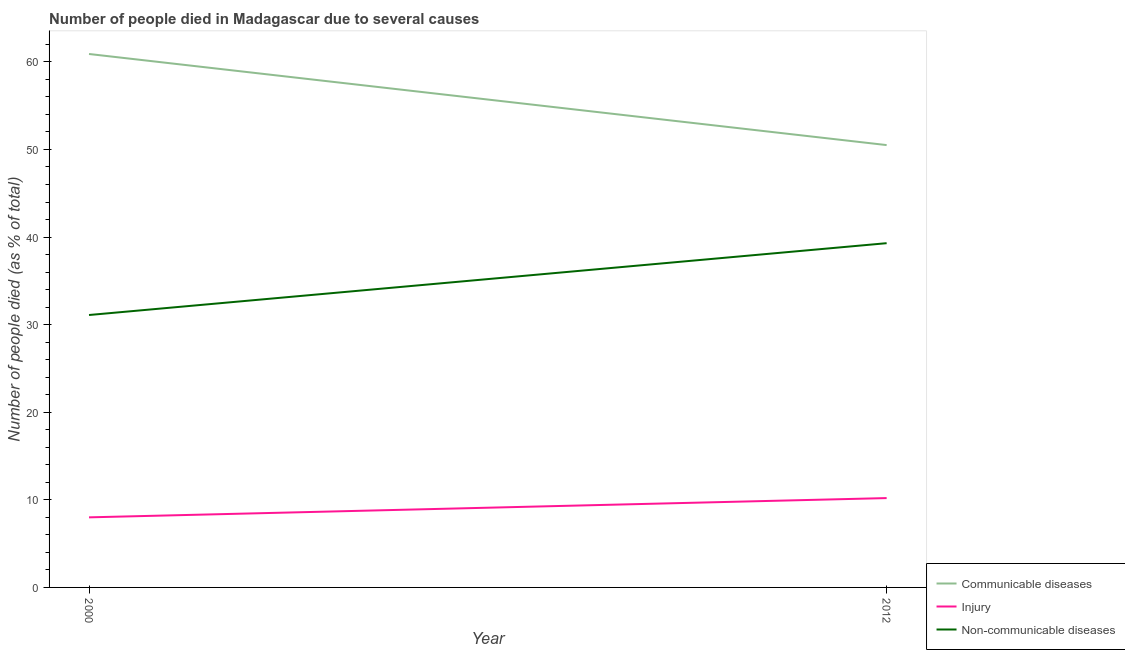Does the line corresponding to number of people who died of communicable diseases intersect with the line corresponding to number of people who died of injury?
Keep it short and to the point. No. Is the number of lines equal to the number of legend labels?
Provide a short and direct response. Yes. What is the number of people who dies of non-communicable diseases in 2012?
Your response must be concise. 39.3. Across all years, what is the maximum number of people who dies of non-communicable diseases?
Give a very brief answer. 39.3. In which year was the number of people who died of injury minimum?
Your answer should be compact. 2000. What is the total number of people who dies of non-communicable diseases in the graph?
Keep it short and to the point. 70.4. What is the difference between the number of people who died of injury in 2000 and that in 2012?
Your response must be concise. -2.2. What is the difference between the number of people who died of communicable diseases in 2012 and the number of people who died of injury in 2000?
Provide a succinct answer. 42.5. What is the average number of people who died of communicable diseases per year?
Give a very brief answer. 55.7. In the year 2012, what is the difference between the number of people who died of injury and number of people who dies of non-communicable diseases?
Offer a terse response. -29.1. In how many years, is the number of people who dies of non-communicable diseases greater than 8 %?
Your response must be concise. 2. What is the ratio of the number of people who died of communicable diseases in 2000 to that in 2012?
Offer a terse response. 1.21. Is the number of people who died of injury in 2000 less than that in 2012?
Keep it short and to the point. Yes. Is it the case that in every year, the sum of the number of people who died of communicable diseases and number of people who died of injury is greater than the number of people who dies of non-communicable diseases?
Keep it short and to the point. Yes. Is the number of people who died of communicable diseases strictly greater than the number of people who died of injury over the years?
Keep it short and to the point. Yes. Is the number of people who died of injury strictly less than the number of people who died of communicable diseases over the years?
Ensure brevity in your answer.  Yes. How many years are there in the graph?
Your response must be concise. 2. Are the values on the major ticks of Y-axis written in scientific E-notation?
Ensure brevity in your answer.  No. Does the graph contain grids?
Your response must be concise. No. Where does the legend appear in the graph?
Your answer should be very brief. Bottom right. What is the title of the graph?
Your answer should be compact. Number of people died in Madagascar due to several causes. What is the label or title of the X-axis?
Keep it short and to the point. Year. What is the label or title of the Y-axis?
Your answer should be compact. Number of people died (as % of total). What is the Number of people died (as % of total) of Communicable diseases in 2000?
Offer a terse response. 60.9. What is the Number of people died (as % of total) in Non-communicable diseases in 2000?
Your response must be concise. 31.1. What is the Number of people died (as % of total) in Communicable diseases in 2012?
Provide a short and direct response. 50.5. What is the Number of people died (as % of total) of Non-communicable diseases in 2012?
Your answer should be very brief. 39.3. Across all years, what is the maximum Number of people died (as % of total) in Communicable diseases?
Make the answer very short. 60.9. Across all years, what is the maximum Number of people died (as % of total) of Non-communicable diseases?
Your answer should be very brief. 39.3. Across all years, what is the minimum Number of people died (as % of total) of Communicable diseases?
Your answer should be very brief. 50.5. Across all years, what is the minimum Number of people died (as % of total) in Injury?
Provide a succinct answer. 8. Across all years, what is the minimum Number of people died (as % of total) in Non-communicable diseases?
Give a very brief answer. 31.1. What is the total Number of people died (as % of total) in Communicable diseases in the graph?
Keep it short and to the point. 111.4. What is the total Number of people died (as % of total) in Non-communicable diseases in the graph?
Your answer should be compact. 70.4. What is the difference between the Number of people died (as % of total) of Communicable diseases in 2000 and that in 2012?
Offer a very short reply. 10.4. What is the difference between the Number of people died (as % of total) of Injury in 2000 and that in 2012?
Offer a very short reply. -2.2. What is the difference between the Number of people died (as % of total) of Non-communicable diseases in 2000 and that in 2012?
Provide a succinct answer. -8.2. What is the difference between the Number of people died (as % of total) of Communicable diseases in 2000 and the Number of people died (as % of total) of Injury in 2012?
Your answer should be compact. 50.7. What is the difference between the Number of people died (as % of total) of Communicable diseases in 2000 and the Number of people died (as % of total) of Non-communicable diseases in 2012?
Keep it short and to the point. 21.6. What is the difference between the Number of people died (as % of total) in Injury in 2000 and the Number of people died (as % of total) in Non-communicable diseases in 2012?
Provide a short and direct response. -31.3. What is the average Number of people died (as % of total) of Communicable diseases per year?
Provide a short and direct response. 55.7. What is the average Number of people died (as % of total) of Non-communicable diseases per year?
Give a very brief answer. 35.2. In the year 2000, what is the difference between the Number of people died (as % of total) in Communicable diseases and Number of people died (as % of total) in Injury?
Your answer should be compact. 52.9. In the year 2000, what is the difference between the Number of people died (as % of total) in Communicable diseases and Number of people died (as % of total) in Non-communicable diseases?
Your answer should be compact. 29.8. In the year 2000, what is the difference between the Number of people died (as % of total) in Injury and Number of people died (as % of total) in Non-communicable diseases?
Provide a succinct answer. -23.1. In the year 2012, what is the difference between the Number of people died (as % of total) of Communicable diseases and Number of people died (as % of total) of Injury?
Give a very brief answer. 40.3. In the year 2012, what is the difference between the Number of people died (as % of total) of Injury and Number of people died (as % of total) of Non-communicable diseases?
Ensure brevity in your answer.  -29.1. What is the ratio of the Number of people died (as % of total) of Communicable diseases in 2000 to that in 2012?
Make the answer very short. 1.21. What is the ratio of the Number of people died (as % of total) of Injury in 2000 to that in 2012?
Offer a terse response. 0.78. What is the ratio of the Number of people died (as % of total) in Non-communicable diseases in 2000 to that in 2012?
Provide a succinct answer. 0.79. What is the difference between the highest and the second highest Number of people died (as % of total) of Communicable diseases?
Offer a terse response. 10.4. What is the difference between the highest and the second highest Number of people died (as % of total) of Injury?
Give a very brief answer. 2.2. What is the difference between the highest and the second highest Number of people died (as % of total) of Non-communicable diseases?
Provide a succinct answer. 8.2. What is the difference between the highest and the lowest Number of people died (as % of total) in Communicable diseases?
Keep it short and to the point. 10.4. What is the difference between the highest and the lowest Number of people died (as % of total) of Injury?
Offer a terse response. 2.2. 